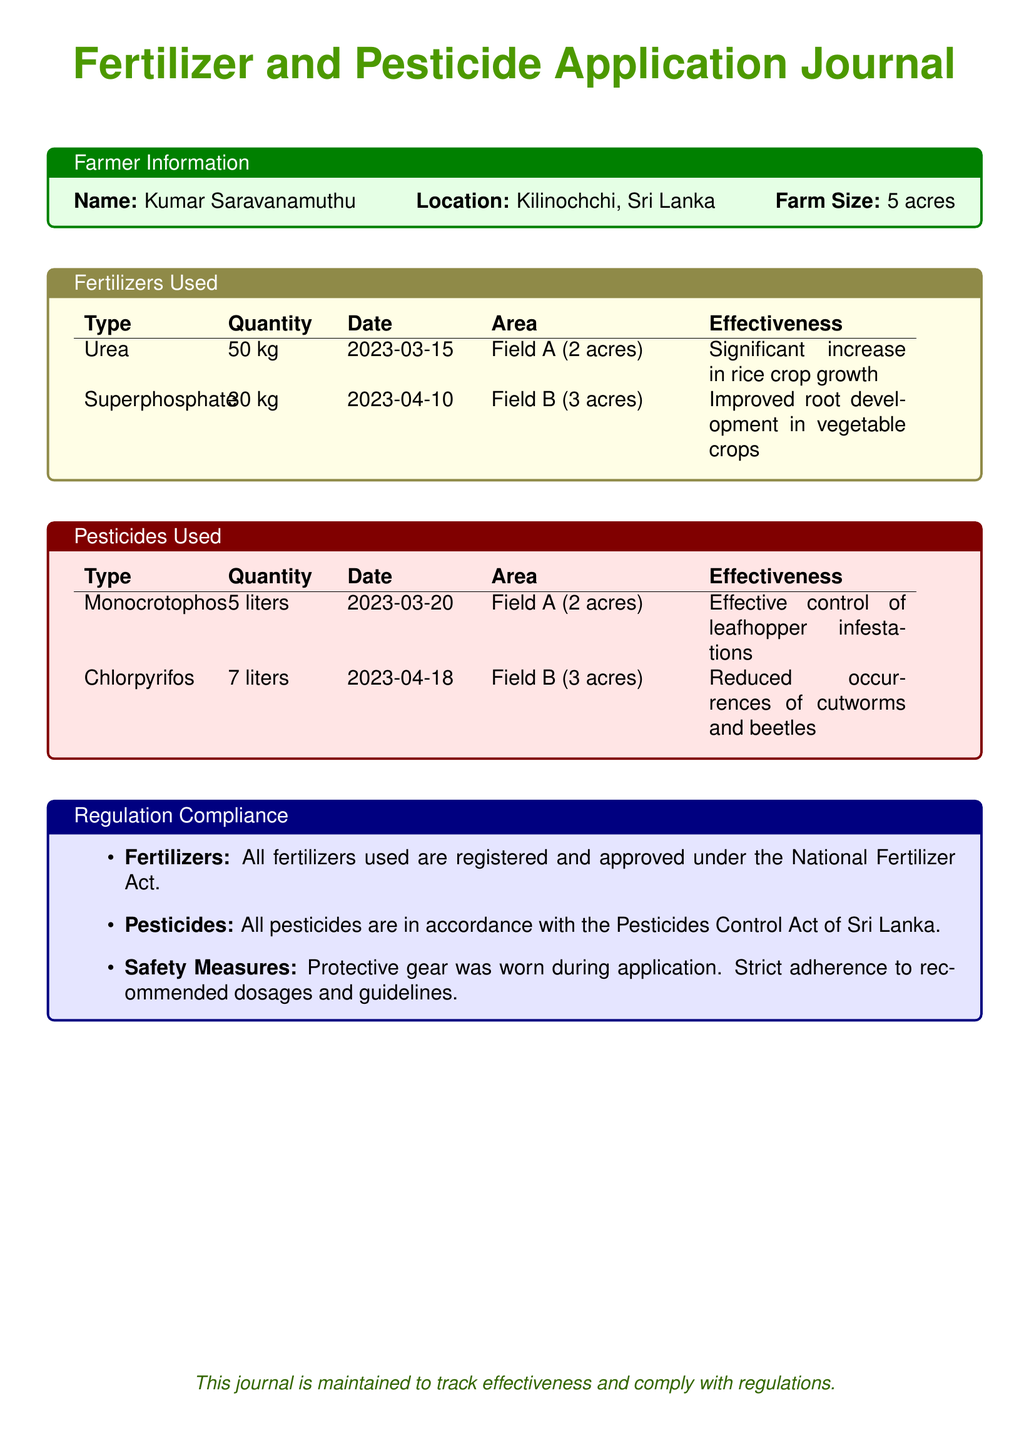What is the name of the farmer? The name of the farmer is listed at the top of the document under Farmer Information.
Answer: Kumar Saravanamuthu What is the size of the farm? The size of the farm is mentioned in the Farmer Information section.
Answer: 5 acres What type of fertilizer was applied on 2023-03-15? The type of fertilizer for the date 2023-03-15 is specified in the Fertilizers Used table.
Answer: Urea How many liters of Monocrotophos were used? The quantity used for Monocrotophos is recorded in the Pesticides Used table.
Answer: 5 liters What area did the Superphosphate cover? The area for Superphosphate is indicated in the Fertilizers Used table.
Answer: Field B (3 acres) What was the effectiveness of Chlorpyrifos? The effectiveness is described in the Pesticides Used table for Chlorpyrifos.
Answer: Reduced occurrences of cutworms and beetles How many kilograms of Superphosphate were used? The quantity of Superphosphate can be found in the Fertilizers Used section.
Answer: 30 kg Which act regulates the fertilizers used? The document specifies which act governs the fertilizers in the Regulation Compliance section.
Answer: National Fertilizer Act What safety measures were followed during application? The safety measures mentioned in the Regulation Compliance section detail the precautions taken.
Answer: Protective gear was worn during application 